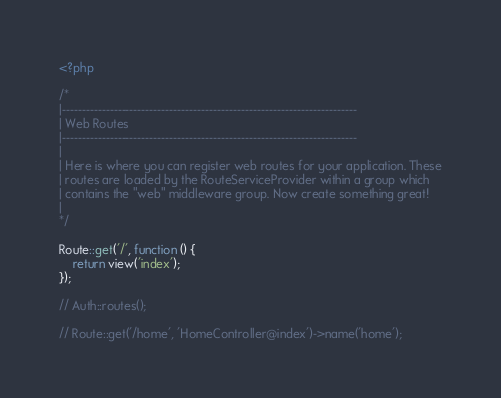<code> <loc_0><loc_0><loc_500><loc_500><_PHP_><?php

/*
|--------------------------------------------------------------------------
| Web Routes
|--------------------------------------------------------------------------
|
| Here is where you can register web routes for your application. These
| routes are loaded by the RouteServiceProvider within a group which
| contains the "web" middleware group. Now create something great!
|
*/

Route::get('/', function () {
    return view('index');
});

// Auth::routes();

// Route::get('/home', 'HomeController@index')->name('home');
</code> 